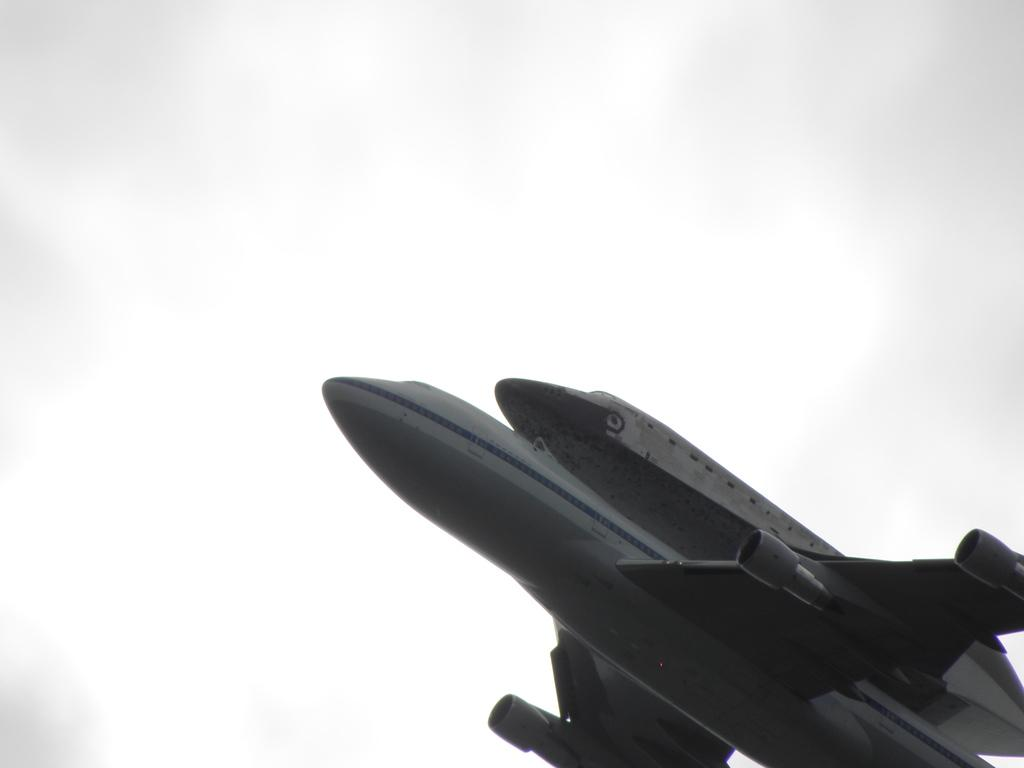What is the main subject of the image? The main subject of the image is a plane. What can be seen in the background of the image? The sky is visible behind the plane. What type of chin can be seen on the plane in the image? There is no chin present on the plane in the image, as planes do not have chins. 